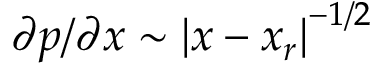Convert formula to latex. <formula><loc_0><loc_0><loc_500><loc_500>\partial p / \partial x \sim \left | x - x _ { r } \right | ^ { - 1 / 2 }</formula> 